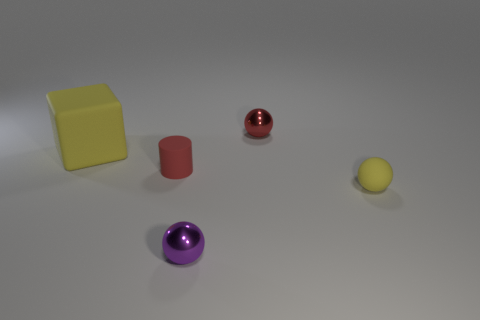How many things are big yellow matte things or tiny objects that are behind the tiny purple ball?
Keep it short and to the point. 4. Is there a shiny sphere that has the same color as the rubber cube?
Keep it short and to the point. No. What number of yellow objects are small rubber cylinders or metallic objects?
Your response must be concise. 0. How many other objects are the same size as the yellow block?
Ensure brevity in your answer.  0. How many big objects are either gray things or red objects?
Offer a terse response. 0. There is a red ball; does it have the same size as the yellow object to the left of the red metallic ball?
Make the answer very short. No. How many other objects are there of the same shape as the small red matte thing?
Your response must be concise. 0. What is the shape of the tiny object that is made of the same material as the purple ball?
Make the answer very short. Sphere. Are any tiny yellow shiny objects visible?
Your response must be concise. No. Are there fewer tiny yellow matte spheres to the left of the yellow cube than objects left of the small purple metallic ball?
Your answer should be compact. Yes. 